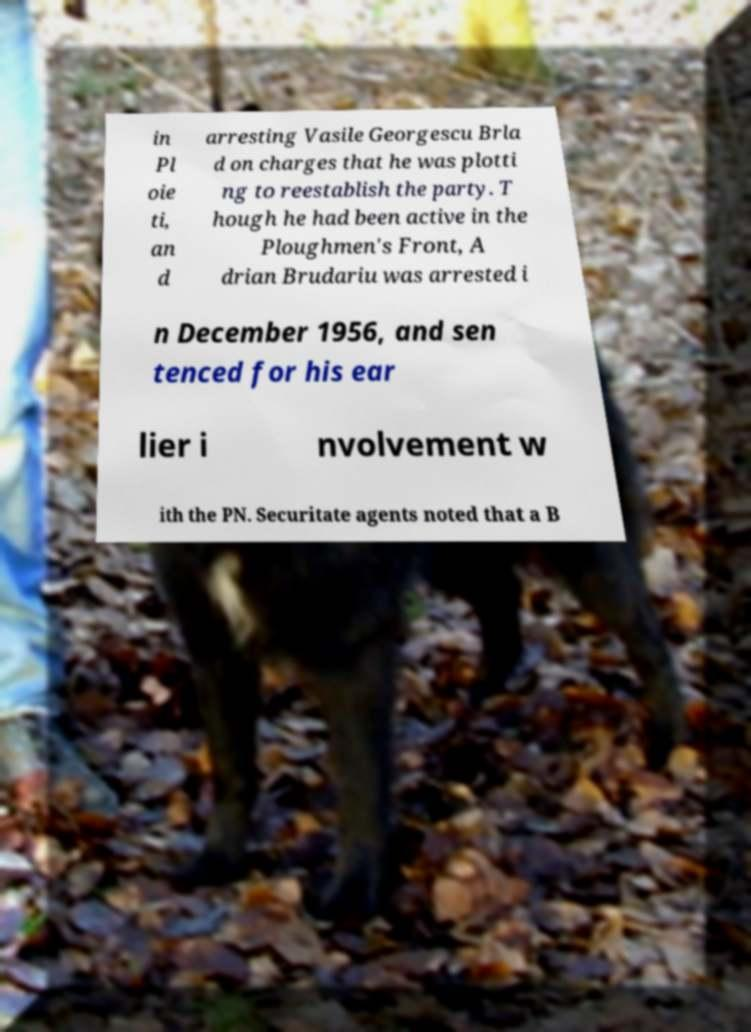I need the written content from this picture converted into text. Can you do that? in Pl oie ti, an d arresting Vasile Georgescu Brla d on charges that he was plotti ng to reestablish the party. T hough he had been active in the Ploughmen's Front, A drian Brudariu was arrested i n December 1956, and sen tenced for his ear lier i nvolvement w ith the PN. Securitate agents noted that a B 